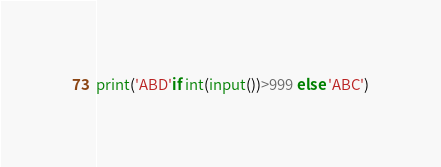<code> <loc_0><loc_0><loc_500><loc_500><_Python_>print('ABD'if int(input())>999 else 'ABC')</code> 